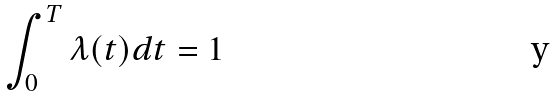Convert formula to latex. <formula><loc_0><loc_0><loc_500><loc_500>\int _ { 0 } ^ { T } \lambda ( t ) d t = 1</formula> 